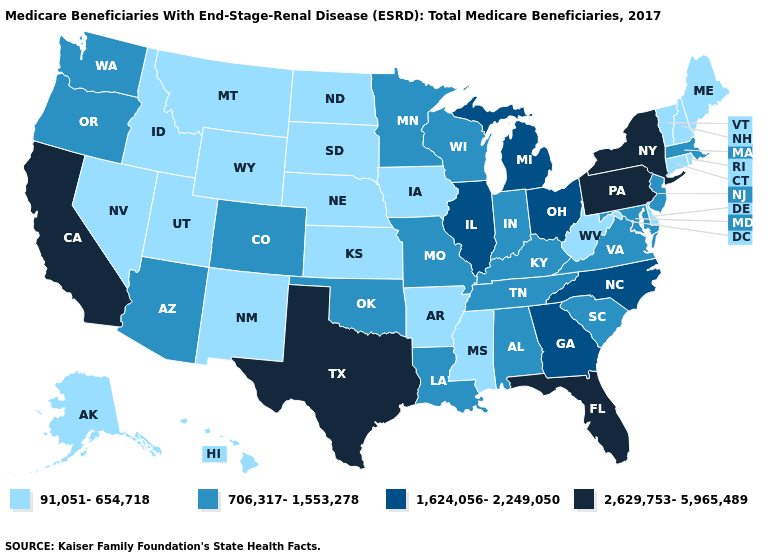Which states hav the highest value in the Northeast?
Short answer required. New York, Pennsylvania. Does Pennsylvania have the highest value in the Northeast?
Keep it brief. Yes. What is the value of West Virginia?
Quick response, please. 91,051-654,718. Which states hav the highest value in the MidWest?
Write a very short answer. Illinois, Michigan, Ohio. Which states have the lowest value in the USA?
Quick response, please. Alaska, Arkansas, Connecticut, Delaware, Hawaii, Idaho, Iowa, Kansas, Maine, Mississippi, Montana, Nebraska, Nevada, New Hampshire, New Mexico, North Dakota, Rhode Island, South Dakota, Utah, Vermont, West Virginia, Wyoming. What is the value of Tennessee?
Quick response, please. 706,317-1,553,278. What is the value of Missouri?
Give a very brief answer. 706,317-1,553,278. Does the map have missing data?
Concise answer only. No. Name the states that have a value in the range 1,624,056-2,249,050?
Concise answer only. Georgia, Illinois, Michigan, North Carolina, Ohio. What is the value of New Mexico?
Quick response, please. 91,051-654,718. Does Montana have a lower value than North Carolina?
Short answer required. Yes. What is the lowest value in states that border California?
Write a very short answer. 91,051-654,718. Name the states that have a value in the range 1,624,056-2,249,050?
Be succinct. Georgia, Illinois, Michigan, North Carolina, Ohio. What is the value of Vermont?
Give a very brief answer. 91,051-654,718. 